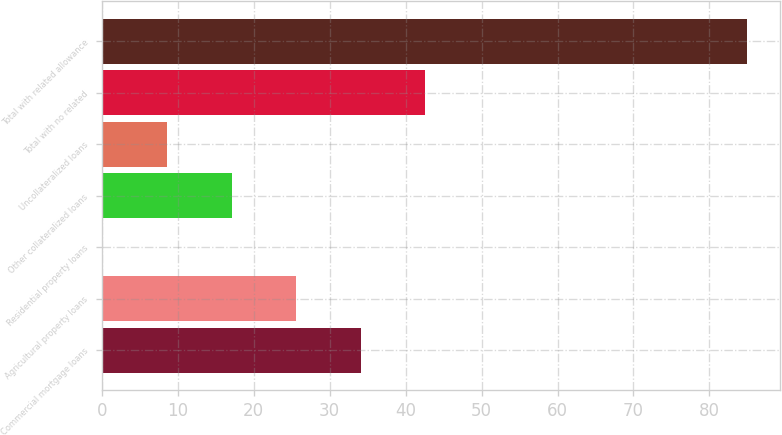<chart> <loc_0><loc_0><loc_500><loc_500><bar_chart><fcel>Commercial mortgage loans<fcel>Agricultural property loans<fcel>Residential property loans<fcel>Other collateralized loans<fcel>Uncollateralized loans<fcel>Total with no related<fcel>Total with related allowance<nl><fcel>34.07<fcel>25.58<fcel>0.11<fcel>17.09<fcel>8.6<fcel>42.56<fcel>85<nl></chart> 